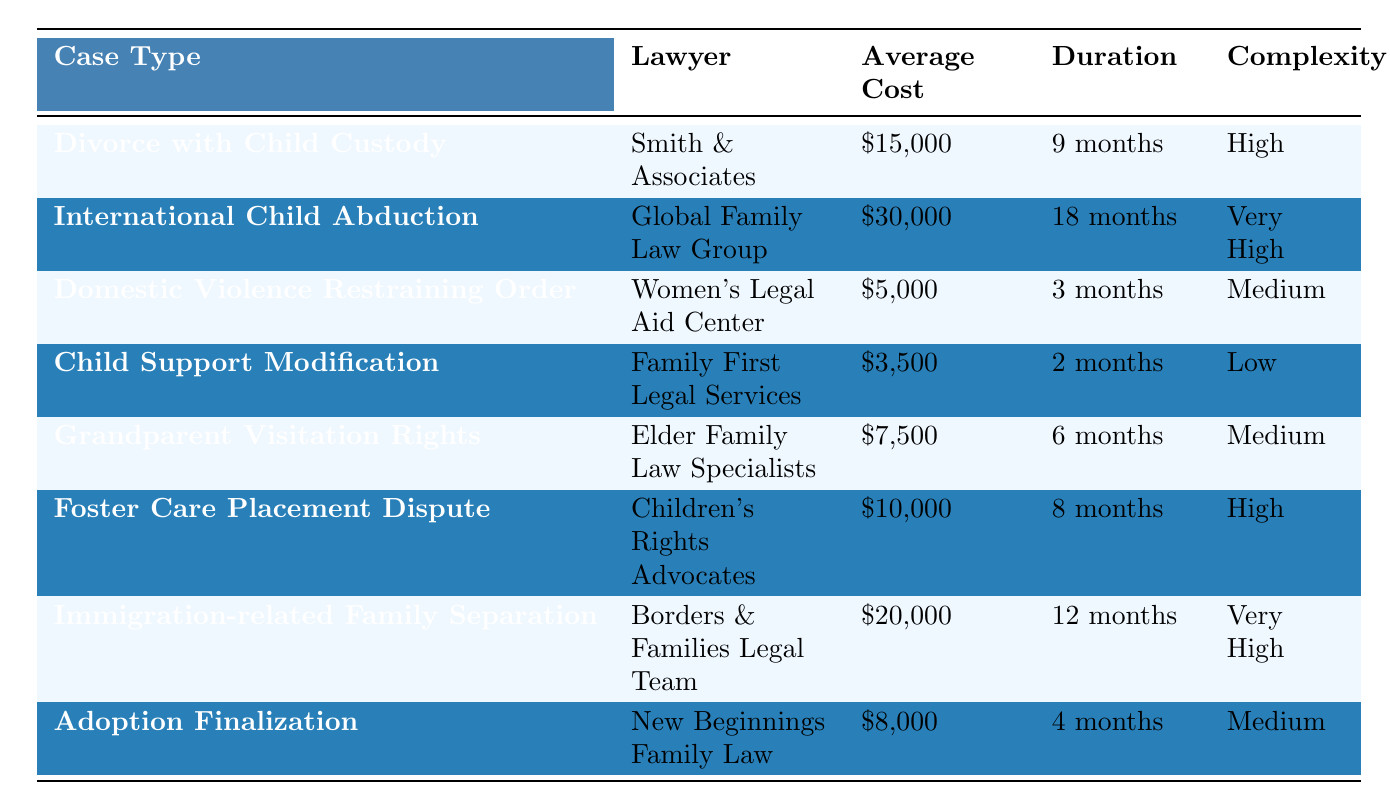What is the average cost of a Divorce with Child Custody case? The table provides the average cost for "Divorce with Child Custody" as $15,000.
Answer: $15,000 Which case type has the highest average cost? Looking through the table, "International Child Abduction" has an average cost of $30,000, which is higher than the other cases listed.
Answer: International Child Abduction How long does it typically take to resolve a Child Support Modification case? According to the table, the duration for "Child Support Modification" is 2 months.
Answer: 2 months Is the complexity level of a Domestic Violence Restraining Order case considered high? Yes, the table indicates that the complexity for "Domestic Violence Restraining Order" is rated as medium, indicating it is not high.
Answer: No What is the difference in average cost between Domestic Violence Restraining Order and Adoption Finalization cases? The average cost of "Domestic Violence Restraining Order" is $5,000 and "Adoption Finalization" is $8,000. The difference is $8,000 - $5,000 = $3,000.
Answer: $3,000 What is the total average cost of resolving all the cases listed in the table? Calculating the total average cost: $15,000 + $30,000 + $5,000 + $3,500 + $7,500 + $10,000 + $20,000 + $8,000 = $99,000.
Answer: $99,000 Among the cases, which one takes the longest duration to resolve? The table shows that "International Child Abduction" has the longest duration of 18 months compared to the other cases.
Answer: International Child Abduction What percentage of the cases have a complexity rated as high or very high? There are 8 cases total. The cases with high complexity are "Divorce with Child Custody," "Foster Care Placement Dispute," and the very high complexity cases are "International Child Abduction" and "Immigration-related Family Separation." That's 5 cases, so the percentage is (5/8) * 100 = 62.5%.
Answer: 62.5% Which lawyer handles the case with the lowest average cost, and what is the cost? The table lists "Child Support Modification" with the lowest average cost at $3,500, which is handled by "Family First Legal Services."
Answer: Family First Legal Services, $3,500 If the average cost for a Grandparent Visitation Rights case decreases by 20%, what will the new average cost be? The original average cost for "Grandparent Visitation Rights" is $7,500. A decrease of 20% is calculated as $7,500 * 0.20 = $1,500. Subtracting gives $7,500 - $1,500 = $6,000.
Answer: $6,000 